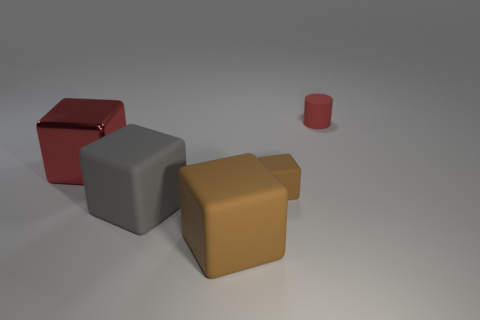There is a cube that is the same size as the red cylinder; what material is it?
Ensure brevity in your answer.  Rubber. What is the material of the object that is both behind the tiny block and left of the small red matte thing?
Your answer should be compact. Metal. There is a large thing that is on the left side of the big gray block; are there any tiny rubber cylinders that are in front of it?
Provide a short and direct response. No. How big is the matte block that is right of the gray rubber block and behind the big brown object?
Your answer should be very brief. Small. How many yellow objects are cylinders or metallic cubes?
Offer a terse response. 0. What shape is the gray object that is the same size as the red shiny cube?
Make the answer very short. Cube. What number of other objects are the same color as the big metallic thing?
Your answer should be very brief. 1. What size is the red thing that is right of the large cube behind the big gray thing?
Keep it short and to the point. Small. Do the large cube that is in front of the large gray rubber thing and the gray cube have the same material?
Your response must be concise. Yes. What is the shape of the red thing left of the small red cylinder?
Keep it short and to the point. Cube. 